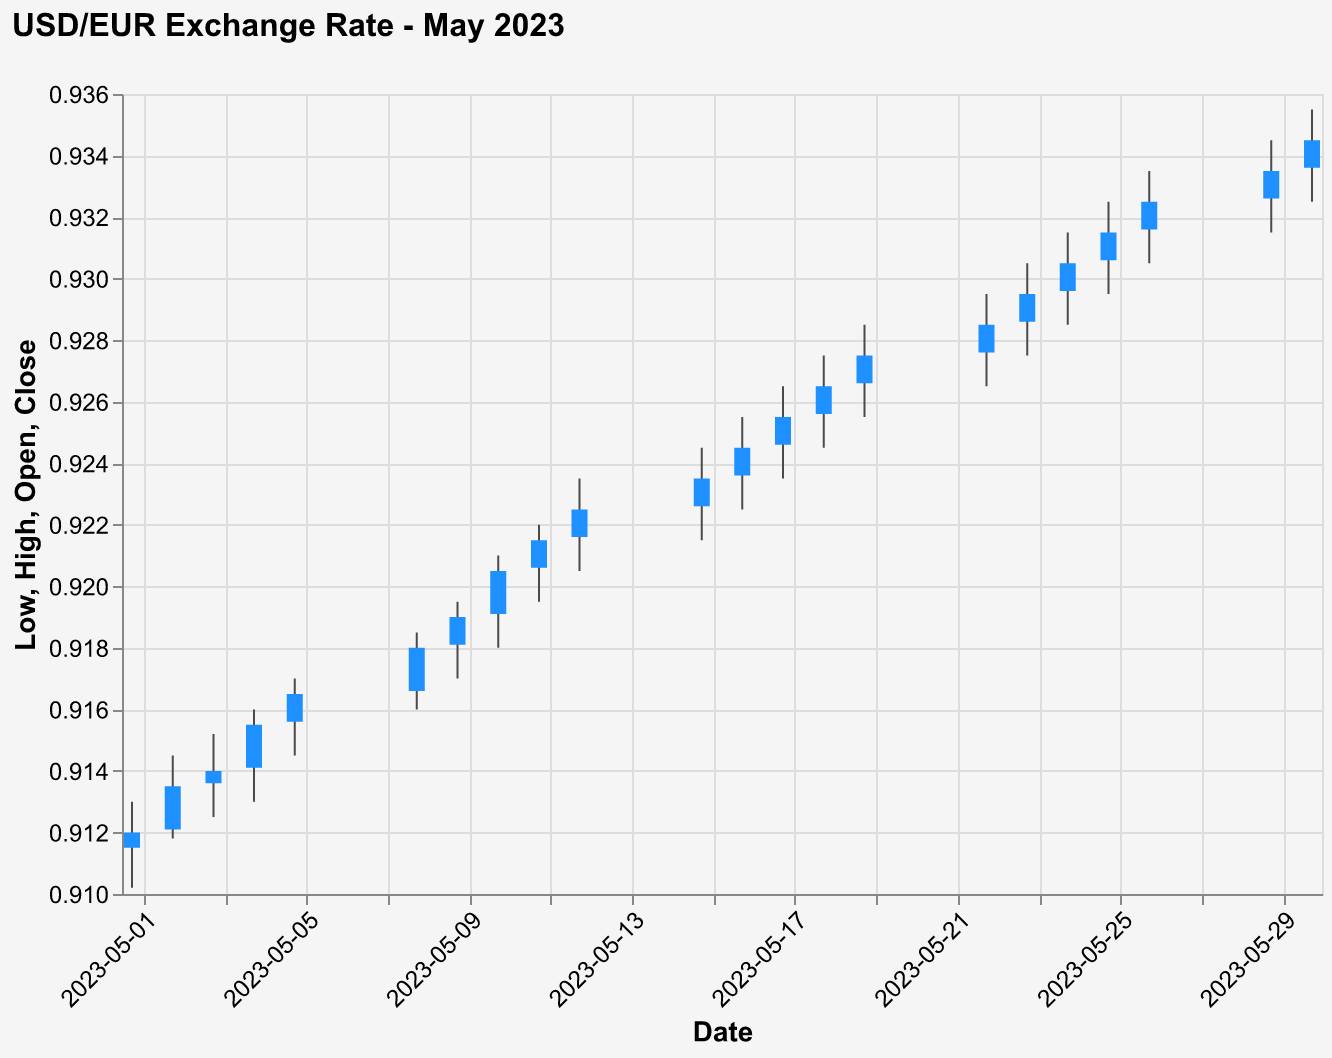What is the title of the figure? The title is displayed prominently at the top of the chart. It reads, "USD/EUR Exchange Rate - May 2023".
Answer: USD/EUR Exchange Rate - May 2023 How many days of data are plotted in the figure? The x-axis lists daily dates for the month of May 2023, starting from May 1 and ending on May 30. Counting these days gives the total number of days plotted.
Answer: 21 What was the highest exchange rate recorded in May 2023? To find this, locate the highest point on the y-axis marked "High" across all dates. The highest value recorded is 0.9355 on May 30.
Answer: 0.9355 Which day had the lowest exchange rate close? Check for the smallest "Close" value on the y-axis throughout the chart. The lowest closing rate is 0.9120 on May 1.
Answer: May 1 What is the average closing rate for the first week of May? To find this, sum the closing rates from May 1 to May 5, then divide by the number of days. (0.9120 + 0.9135 + 0.9140 + 0.9155 + 0.9165) / 5 = 4.5715 / 5 = 0.9143
Answer: 0.9143 Did any day in May 2023 have the same open and close rate? By comparing the "Open" and "Close" values for each day, we see that no days had the same open and close rate.
Answer: No Comparing May 10 and May 11, which day had a higher closing rate? Look for the "Close" values on May 10 (0.9205) and May 11 (0.9215). Since 0.9215 > 0.9205, May 11 had a higher closing rate.
Answer: May 11 What was the closing rate trend from May 8 to May 10? Analyze the "Close" values for May 8 (0.9180), May 9 (0.9190), and May 10 (0.9205). Notice that the rate increased each day.
Answer: Increasing trend What's the difference between the highest and lowest closing rates in May 2023? Subtract the lowest closing rate (0.9120 on May 1) from the highest closing rate (0.9345 on May 30). 0.9345 - 0.9120 = 0.0225
Answer: 0.0225 How does the exchange rate on May 15 compare to that on May 22? Compare the "Close" rates for May 15 (0.9235) and May 22 (0.9285). Since 0.9285 > 0.9235, the rate on May 22 is higher.
Answer: Higher on May 22 